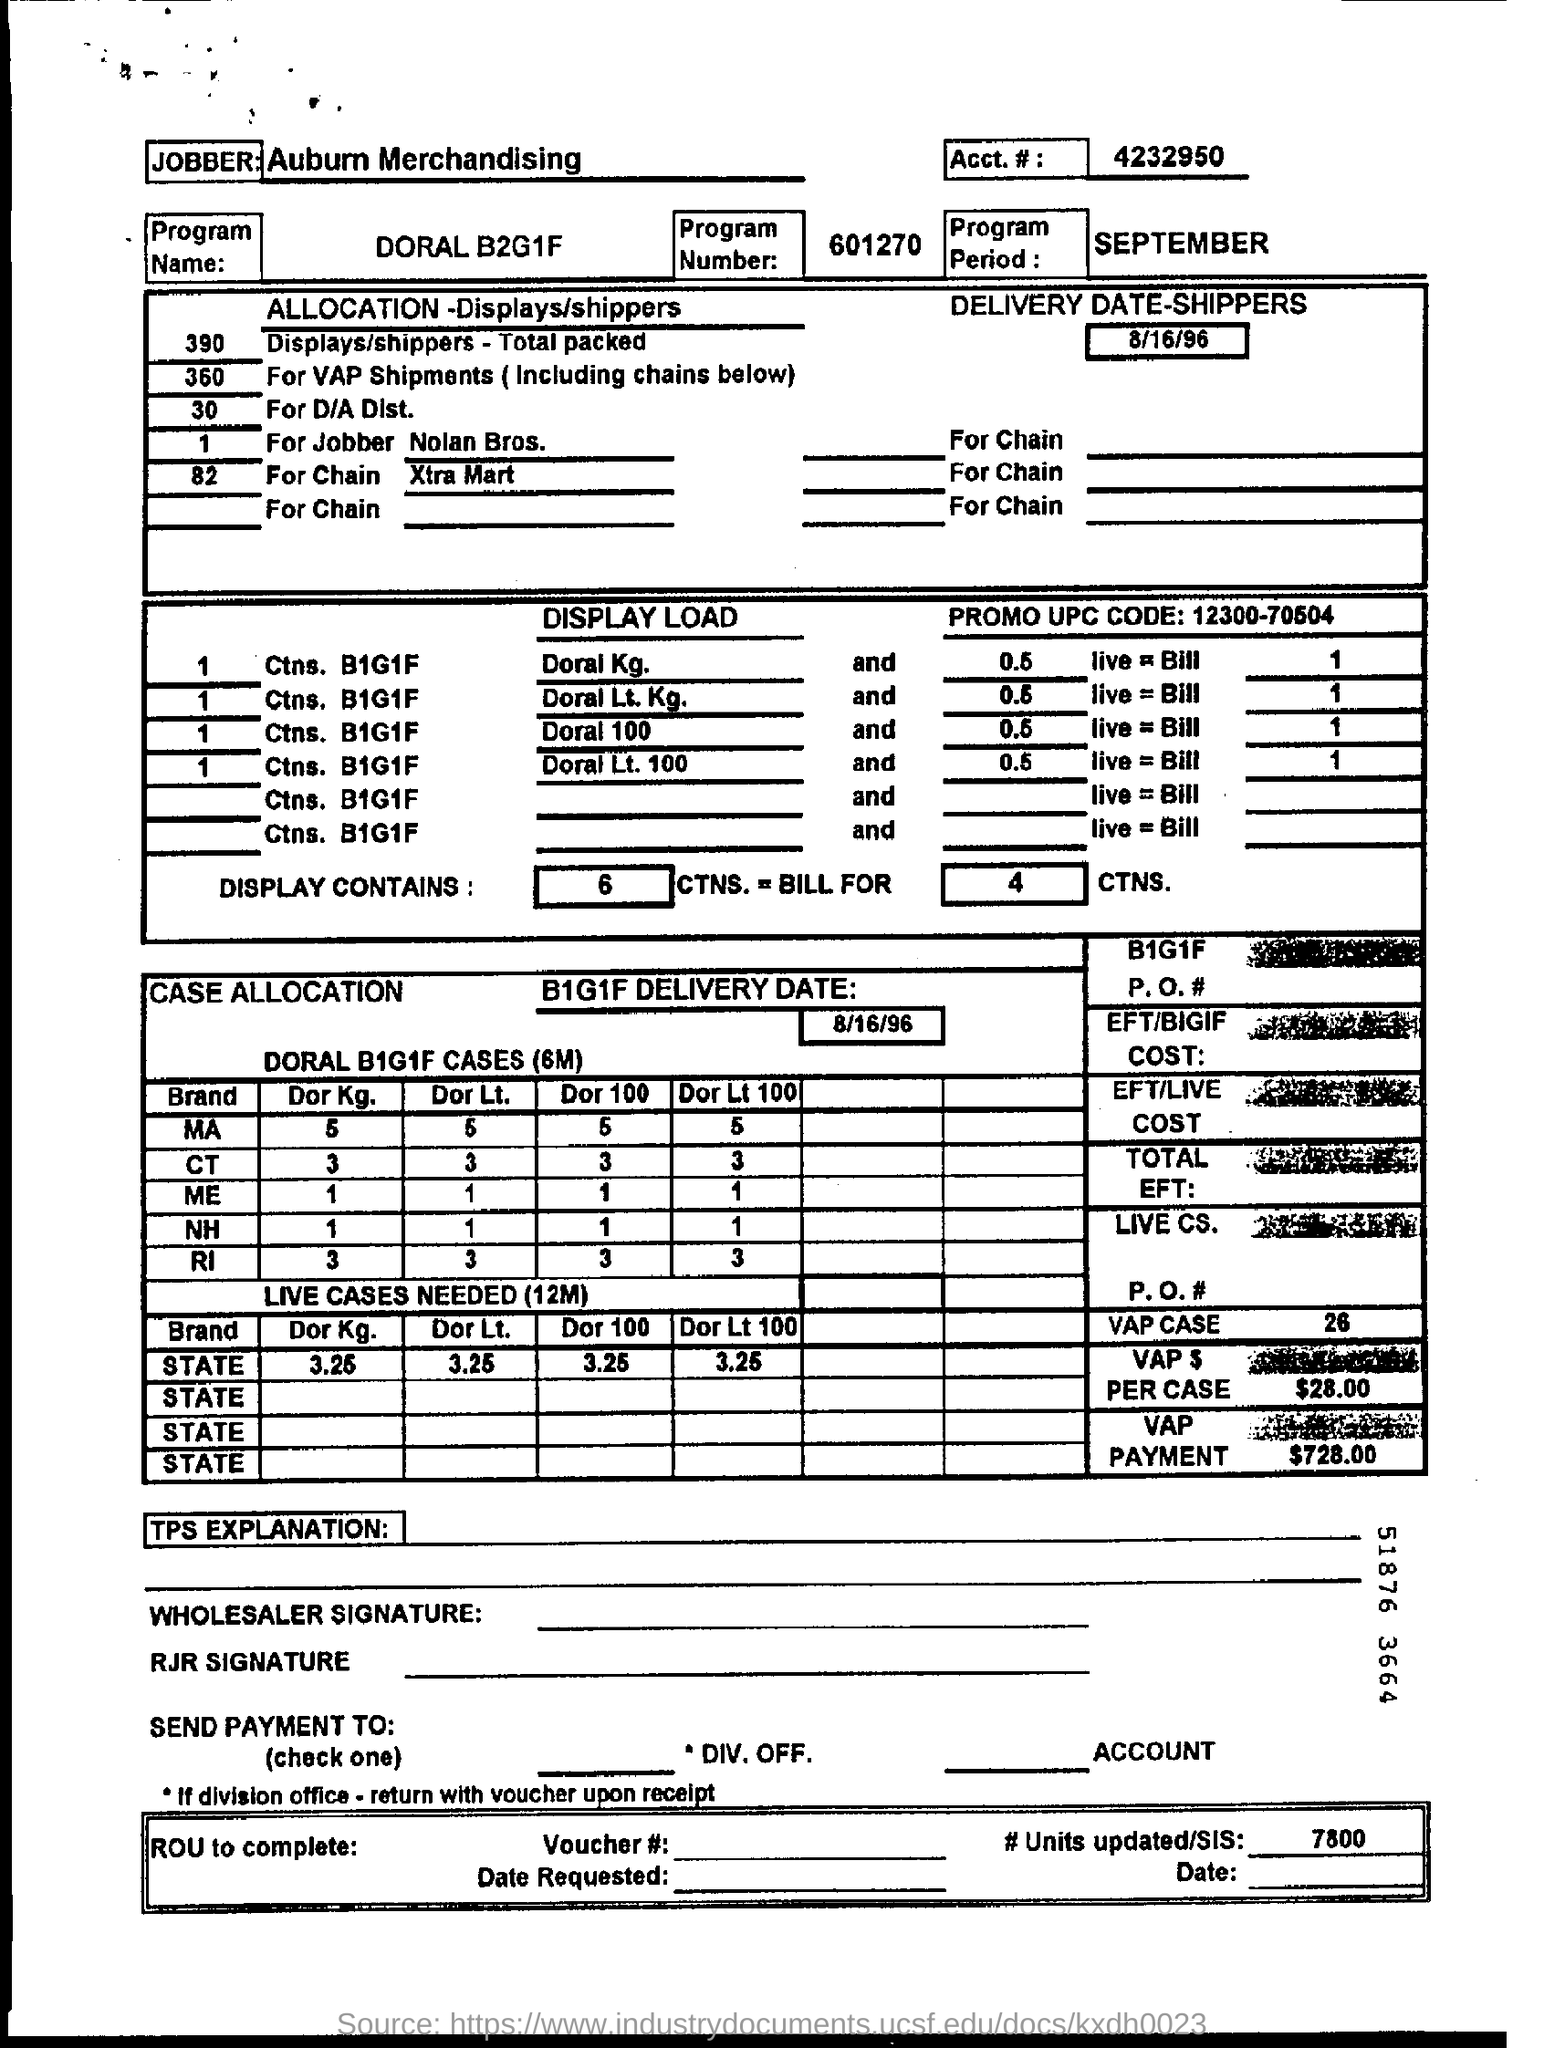What is the program number ?
Your answer should be very brief. 601270. What is the acct# number mentioned ?
Your answer should be compact. 4232950. What is the program name?
Your response must be concise. DORAL B2G1F. What is the b1g1f delivery date?
Offer a very short reply. 8/16/96. How much is the vap payment?
Provide a succinct answer. 728.00. How many #units updated/ sis ?
Ensure brevity in your answer.  7800. What is the promo upc code ?
Your answer should be compact. 12300-70504. 